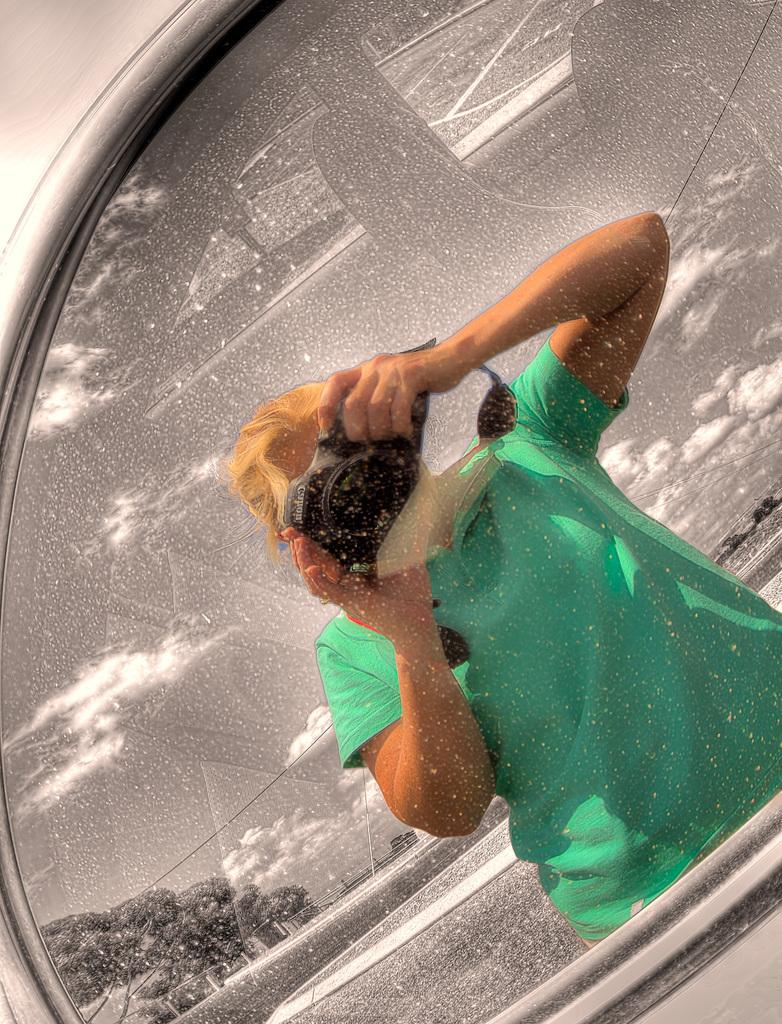What material is present in the image? There is glass in the image. What is the person in the image doing? The person is holding a camera in the image. What can be seen in the background of the image? There are trees and the sky visible in the background of the image. What is the condition of the sky in the image? The sky contains clouds in the image. Can you see any veins in the glass in the image? There are no veins present in the glass in the image, as veins are a biological feature typically found in living organisms. What type of grain is visible in the image? There is no grain present in the image. 